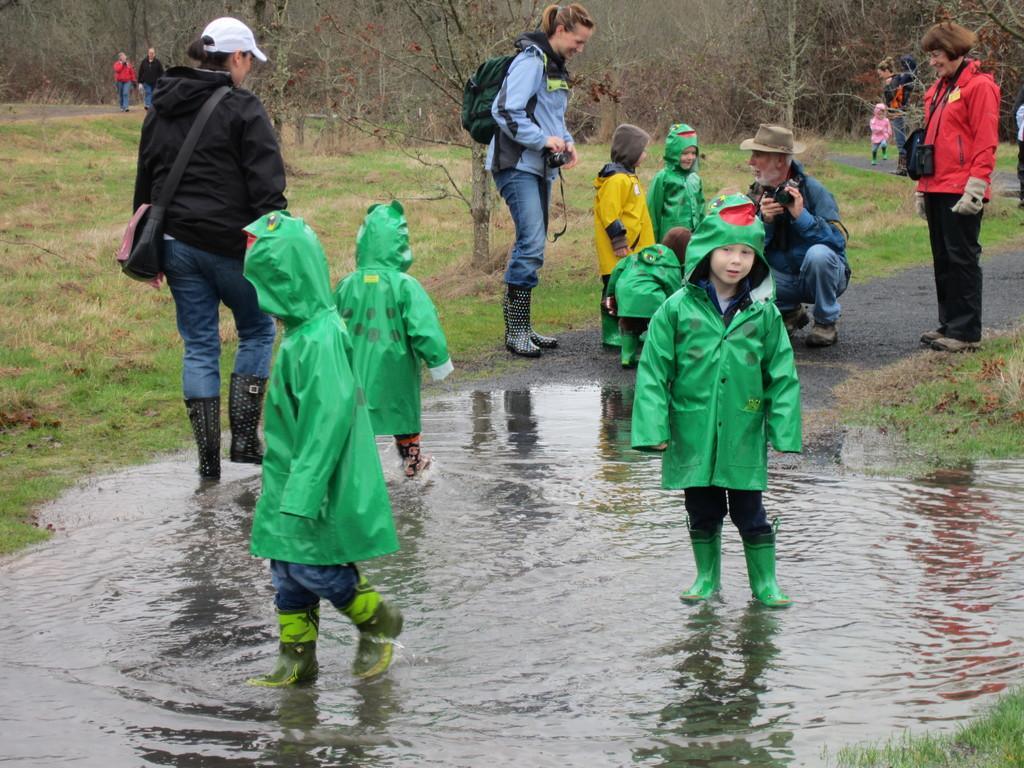In one or two sentences, can you explain what this image depicts? In this image I can see the group of people. These people are wearing the different color dresses and I can see few people with green color coats. I can see few people are on the water. In the back there are many dried trees. 